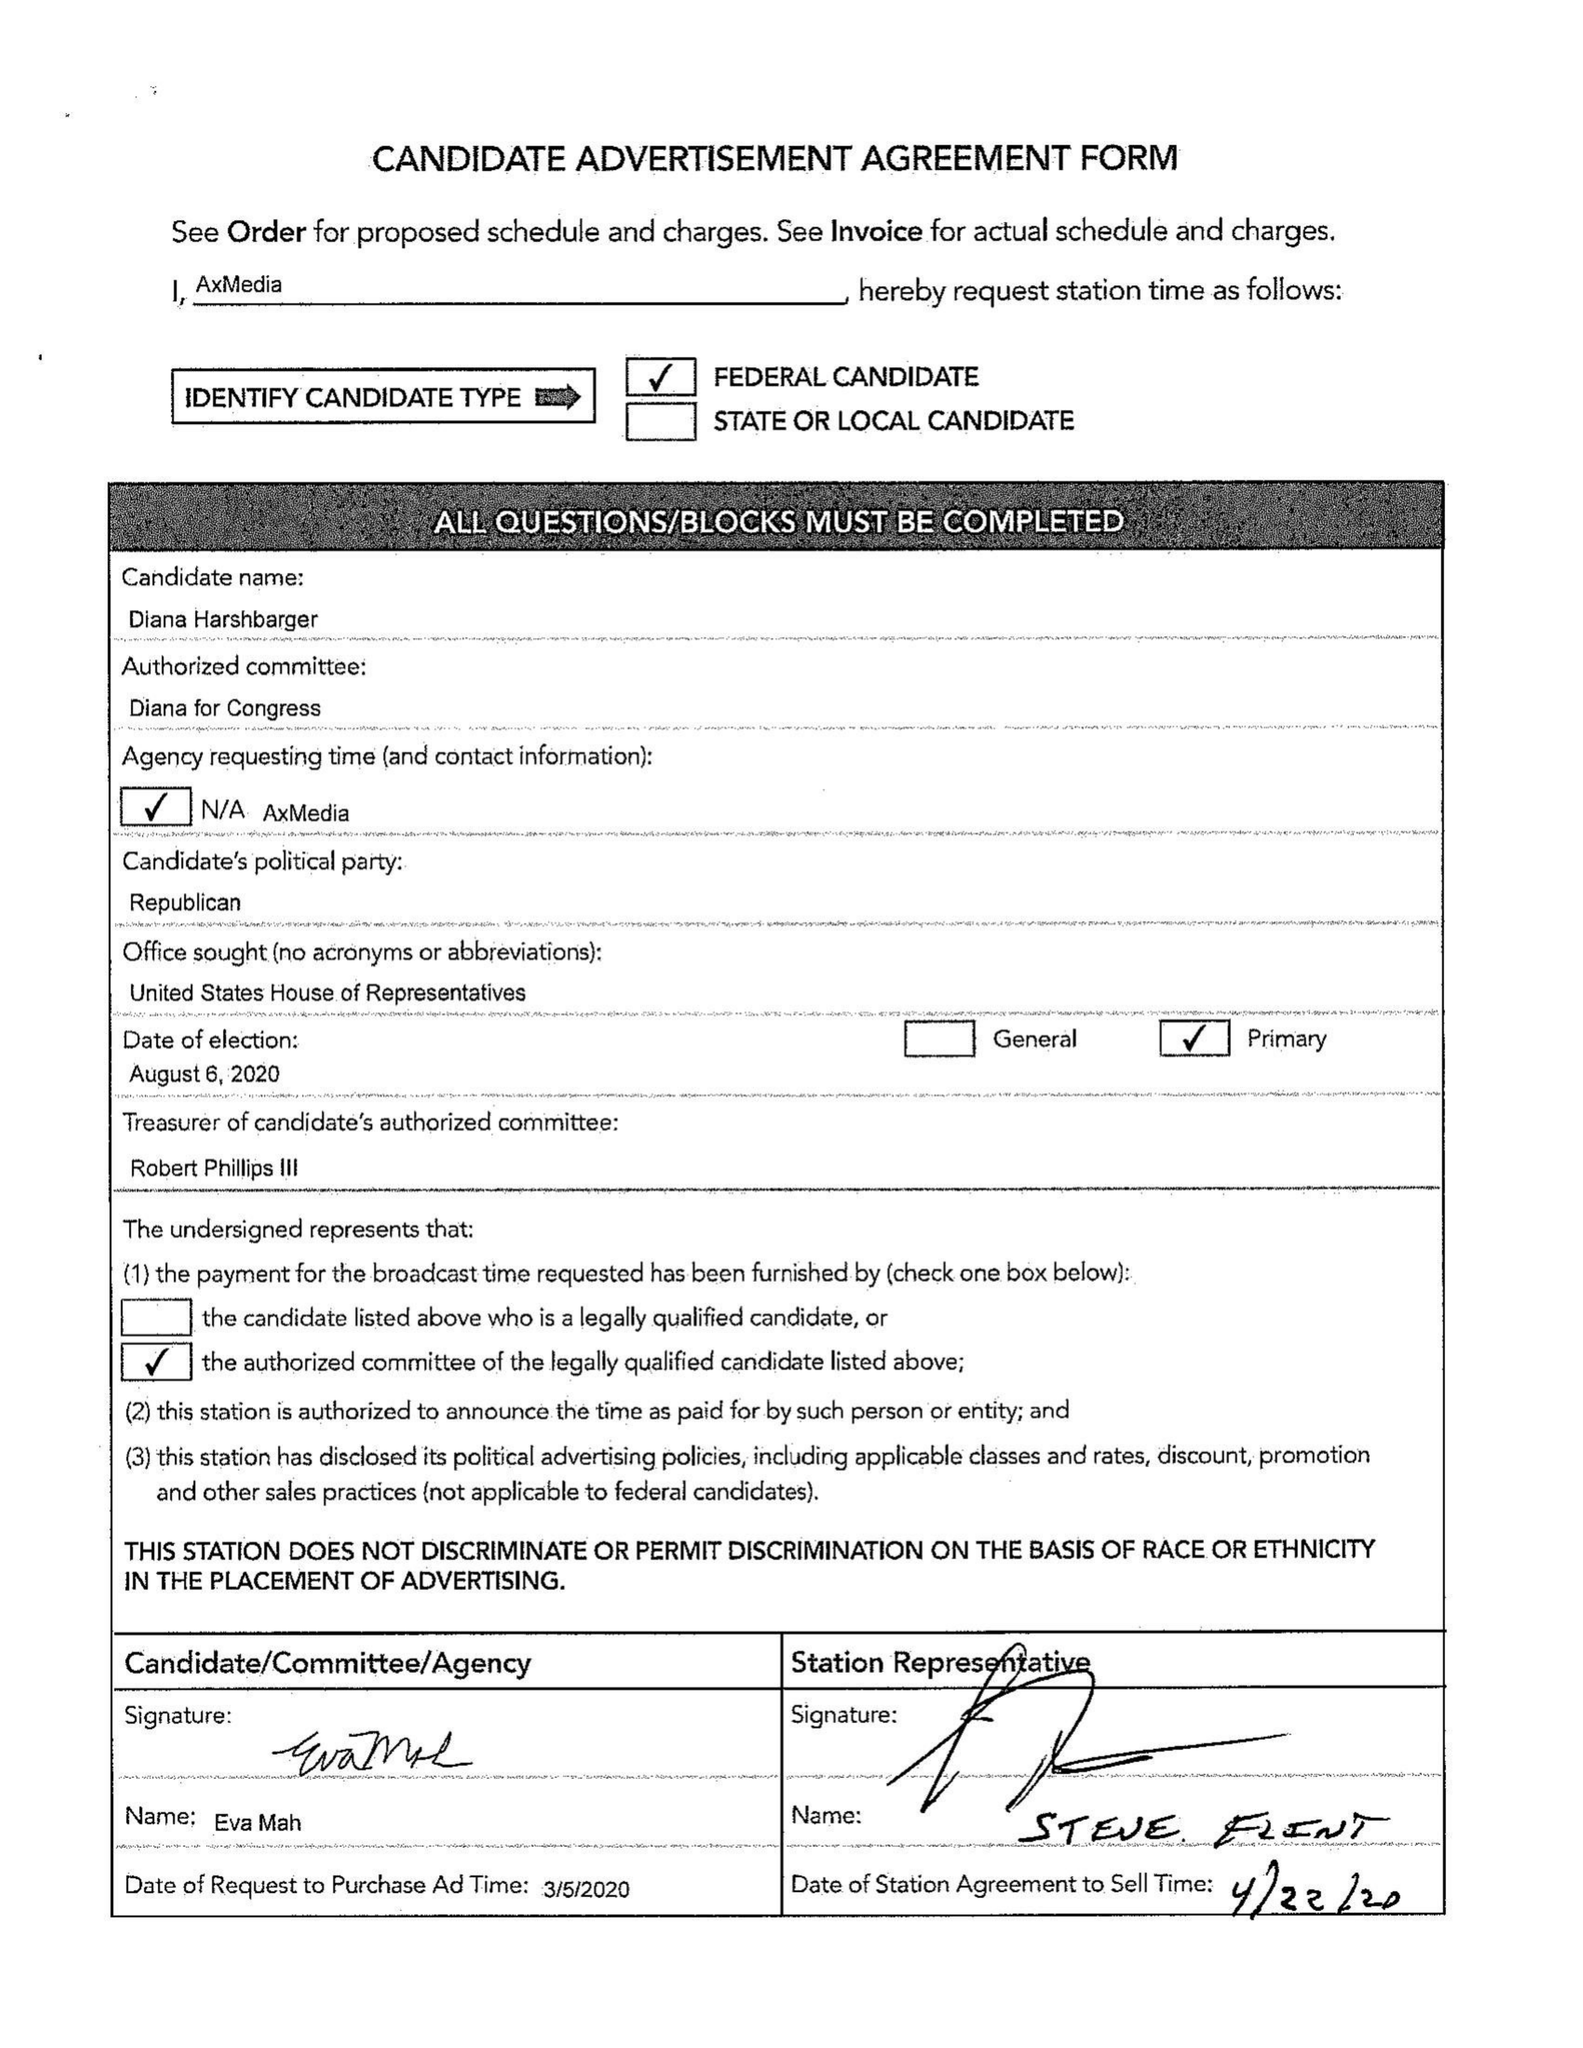What is the value for the flight_from?
Answer the question using a single word or phrase. 03/30/20 